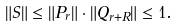<formula> <loc_0><loc_0><loc_500><loc_500>\| S \| \leq \| P _ { r } \| \cdot \| Q _ { r + R } \| \leq 1 .</formula> 